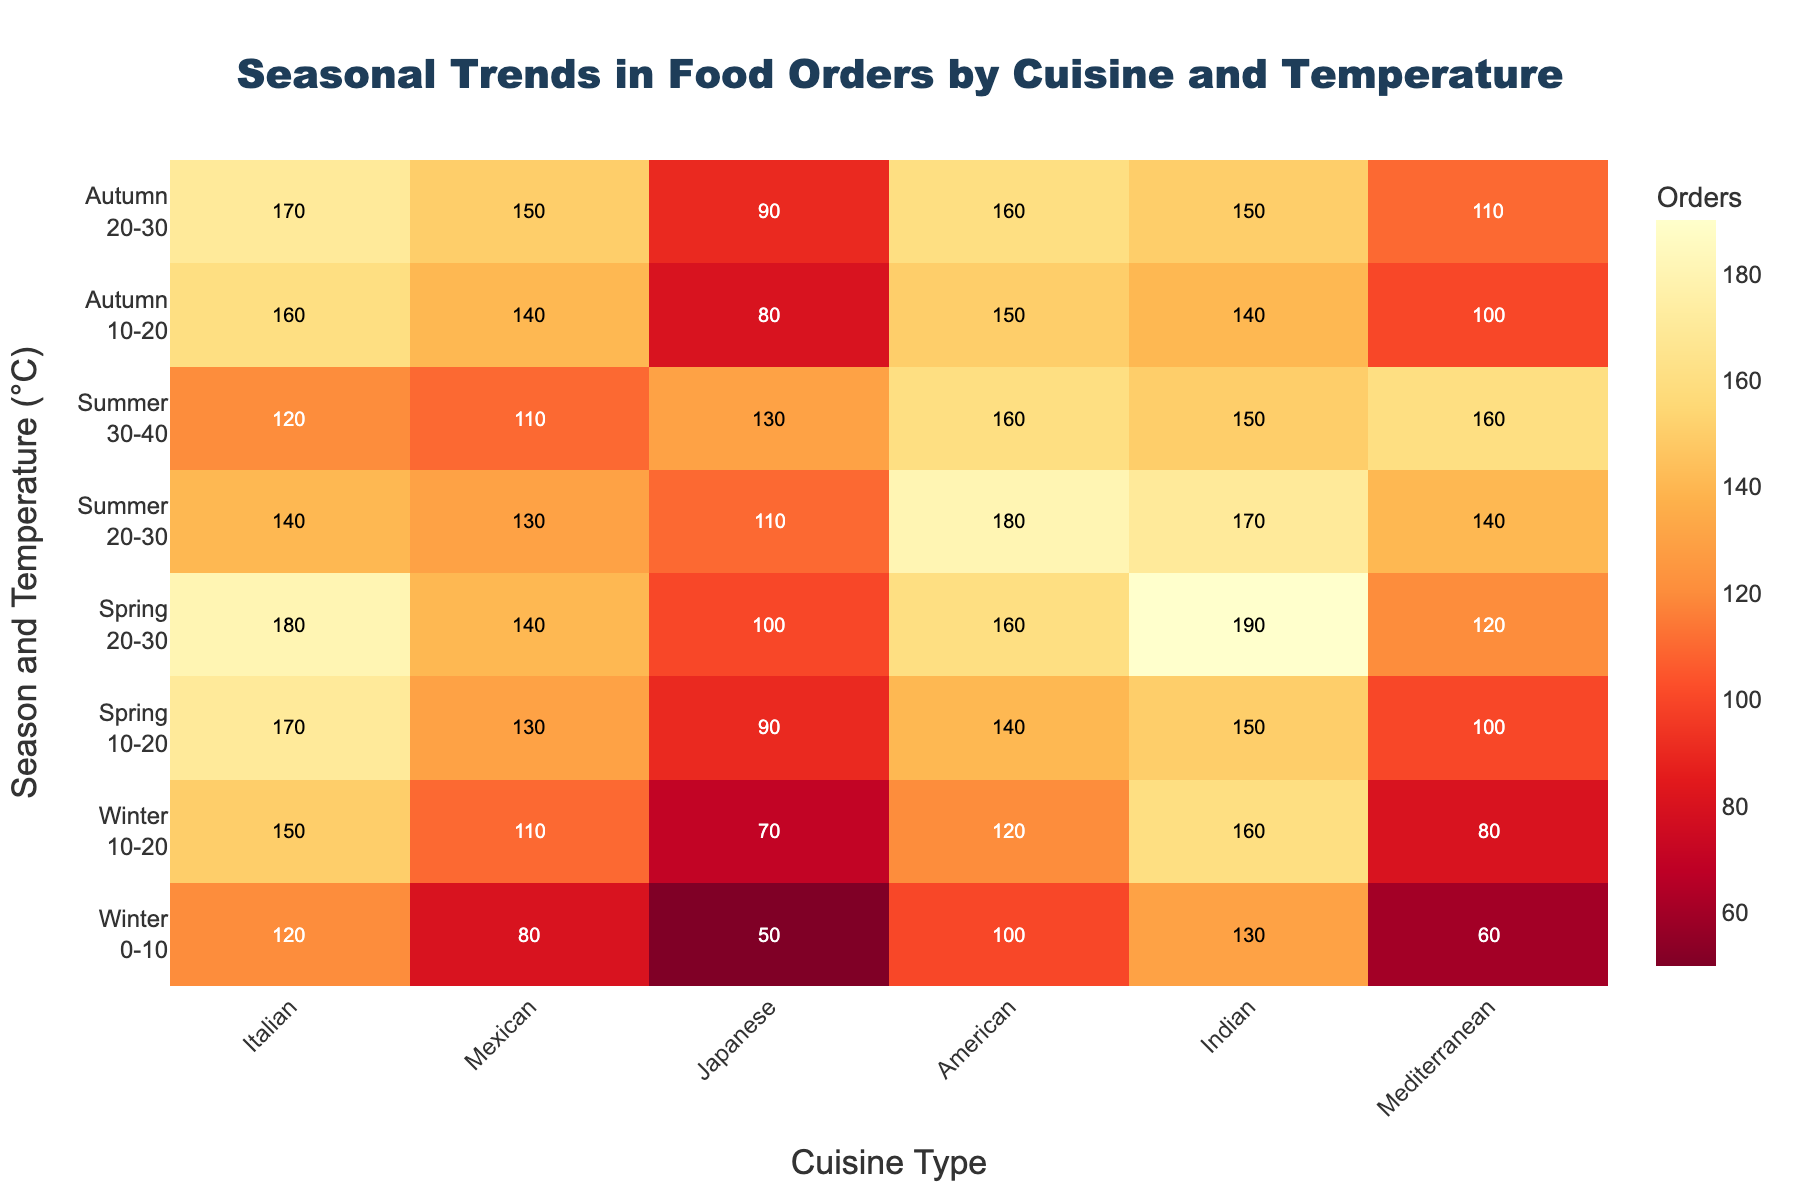What is the title of the heatmap? The title typically appears at the top of the figure. In this case, it is "Seasonal Trends in Food Orders by Cuisine and Temperature" as it summarizes what the heatmap displays.
Answer: Seasonal Trends in Food Orders by Cuisine and Temperature Which cuisine type has the highest number of orders in winter at temperature 10-20°C? Look at the intersection of the row for "Winter<br>10-20" and the columns under "Cuisine Type." You will see various order numbers; the highest is 160 under "Indian."
Answer: Indian What is the sum of orders for Mexican cuisine across all seasons? Identify the order values for Mexican cuisine across all rows: 80 + 110 + 130 + 140 + 130 + 110 + 140 + 150. Adding these gives 990.
Answer: 990 In which season does Japanese cuisine reach its peak orders, and what is the temperature range? Scan the column for Japanese cuisine and find the highest value, which is 130. This corresponds to the row "Summer<br>30-40."
Answer: Summer, 30-40°C How many temperature categories are there in the dataset? Count the unique temperature categories listed along the Y-axis labels.
Answer: Four Is there a trend in the number of food orders for Mediterranean cuisine as the temperature increases from winter to summer? Observe the values for Mediterranean cuisine: 60, 80, 100, 120, 140, 160. It generally increases with temperature.
Answer: Yes Which season and temperature combination saw the highest orders for American cuisine? Identify the maximum value in the American cuisine column, which is 180. This corresponds to "Summer<br>20-30."
Answer: Summer, 20-30°C Compare the total orders for Japanese cuisine in Winter and Summer. Sum the values for Winter: 50 (0-10) + 70 (10-20) = 120. Sum the values for Summer: 110 (20-30) + 130 (30-40) = 240.
Answer: Winter: 120, Summer: 240 What are the colors used for low and high order values in the heatmap? Low order values generally appear yellowish, while high order values are reddish, indicating a range from light to dark colors.
Answer: Yellow, Red How many seasonal and temperature combinations have orders less than 100 for Indian cuisine? Identify the values for Indian cuisine less than 100: Winter (0-10), Winter (10-20), and Spring (10-20) rows, respectively. Total count is 3.
Answer: 3 